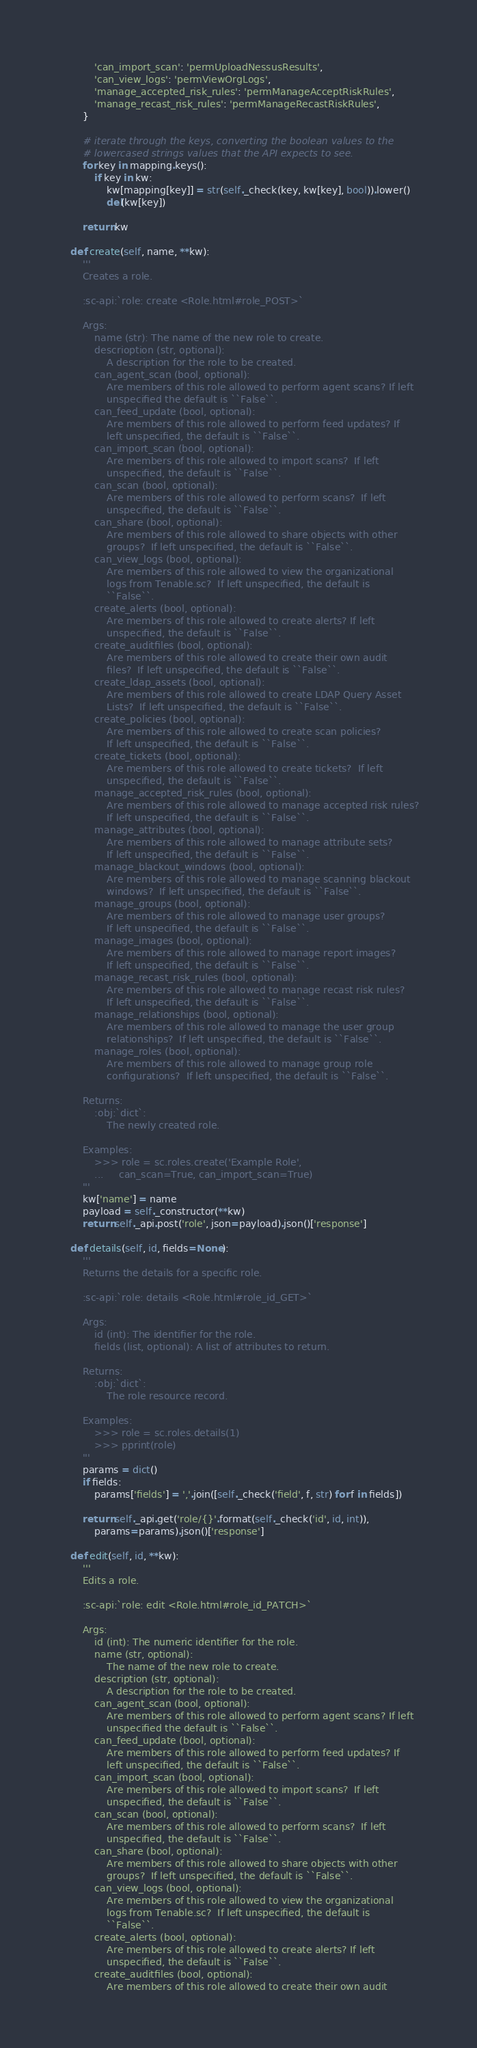<code> <loc_0><loc_0><loc_500><loc_500><_Python_>            'can_import_scan': 'permUploadNessusResults',
            'can_view_logs': 'permViewOrgLogs',
            'manage_accepted_risk_rules': 'permManageAcceptRiskRules',
            'manage_recast_risk_rules': 'permManageRecastRiskRules',
        }

        # iterate through the keys, converting the boolean values to the
        # lowercased strings values that the API expects to see.
        for key in mapping.keys():
            if key in kw:
                kw[mapping[key]] = str(self._check(key, kw[key], bool)).lower()
                del(kw[key])

        return kw

    def create(self, name, **kw):
        '''
        Creates a role.

        :sc-api:`role: create <Role.html#role_POST>`

        Args:
            name (str): The name of the new role to create.
            descrioption (str, optional):
                A description for the role to be created.
            can_agent_scan (bool, optional):
                Are members of this role allowed to perform agent scans? If left
                unspecified the default is ``False``.
            can_feed_update (bool, optional):
                Are members of this role allowed to perform feed updates? If
                left unspecified, the default is ``False``.
            can_import_scan (bool, optional):
                Are members of this role allowed to import scans?  If left
                unspecified, the default is ``False``.
            can_scan (bool, optional):
                Are members of this role allowed to perform scans?  If left
                unspecified, the default is ``False``.
            can_share (bool, optional):
                Are members of this role allowed to share objects with other
                groups?  If left unspecified, the default is ``False``.
            can_view_logs (bool, optional):
                Are members of this role allowed to view the organizational
                logs from Tenable.sc?  If left unspecified, the default is
                ``False``.
            create_alerts (bool, optional):
                Are members of this role allowed to create alerts? If left
                unspecified, the default is ``False``.
            create_auditfiles (bool, optional):
                Are members of this role allowed to create their own audit
                files?  If left unspecified, the default is ``False``.
            create_ldap_assets (bool, optional):
                Are members of this role allowed to create LDAP Query Asset
                Lists?  If left unspecified, the default is ``False``.
            create_policies (bool, optional):
                Are members of this role allowed to create scan policies?
                If left unspecified, the default is ``False``.
            create_tickets (bool, optional):
                Are members of this role allowed to create tickets?  If left
                unspecified, the default is ``False``.
            manage_accepted_risk_rules (bool, optional):
                Are members of this role allowed to manage accepted risk rules?
                If left unspecified, the default is ``False``.
            manage_attributes (bool, optional):
                Are members of this role allowed to manage attribute sets?
                If left unspecified, the default is ``False``.
            manage_blackout_windows (bool, optional):
                Are members of this role allowed to manage scanning blackout
                windows?  If left unspecified, the default is ``False``.
            manage_groups (bool, optional):
                Are members of this role allowed to manage user groups?
                If left unspecified, the default is ``False``.
            manage_images (bool, optional):
                Are members of this role allowed to manage report images?
                If left unspecified, the default is ``False``.
            manage_recast_risk_rules (bool, optional):
                Are members of this role allowed to manage recast risk rules?
                If left unspecified, the default is ``False``.
            manage_relationships (bool, optional):
                Are members of this role allowed to manage the user group
                relationships?  If left unspecified, the default is ``False``.
            manage_roles (bool, optional):
                Are members of this role allowed to manage group role
                configurations?  If left unspecified, the default is ``False``.

        Returns:
            :obj:`dict`:
                The newly created role.

        Examples:
            >>> role = sc.roles.create('Example Role',
            ...     can_scan=True, can_import_scan=True)
        '''
        kw['name'] = name
        payload = self._constructor(**kw)
        return self._api.post('role', json=payload).json()['response']

    def details(self, id, fields=None):
        '''
        Returns the details for a specific role.

        :sc-api:`role: details <Role.html#role_id_GET>`

        Args:
            id (int): The identifier for the role.
            fields (list, optional): A list of attributes to return.

        Returns:
            :obj:`dict`:
                The role resource record.

        Examples:
            >>> role = sc.roles.details(1)
            >>> pprint(role)
        '''
        params = dict()
        if fields:
            params['fields'] = ','.join([self._check('field', f, str) for f in fields])

        return self._api.get('role/{}'.format(self._check('id', id, int)),
            params=params).json()['response']

    def edit(self, id, **kw):
        '''
        Edits a role.

        :sc-api:`role: edit <Role.html#role_id_PATCH>`

        Args:
            id (int): The numeric identifier for the role.
            name (str, optional):
                The name of the new role to create.
            description (str, optional):
                A description for the role to be created.
            can_agent_scan (bool, optional):
                Are members of this role allowed to perform agent scans? If left
                unspecified the default is ``False``.
            can_feed_update (bool, optional):
                Are members of this role allowed to perform feed updates? If
                left unspecified, the default is ``False``.
            can_import_scan (bool, optional):
                Are members of this role allowed to import scans?  If left
                unspecified, the default is ``False``.
            can_scan (bool, optional):
                Are members of this role allowed to perform scans?  If left
                unspecified, the default is ``False``.
            can_share (bool, optional):
                Are members of this role allowed to share objects with other
                groups?  If left unspecified, the default is ``False``.
            can_view_logs (bool, optional):
                Are members of this role allowed to view the organizational
                logs from Tenable.sc?  If left unspecified, the default is
                ``False``.
            create_alerts (bool, optional):
                Are members of this role allowed to create alerts? If left
                unspecified, the default is ``False``.
            create_auditfiles (bool, optional):
                Are members of this role allowed to create their own audit</code> 